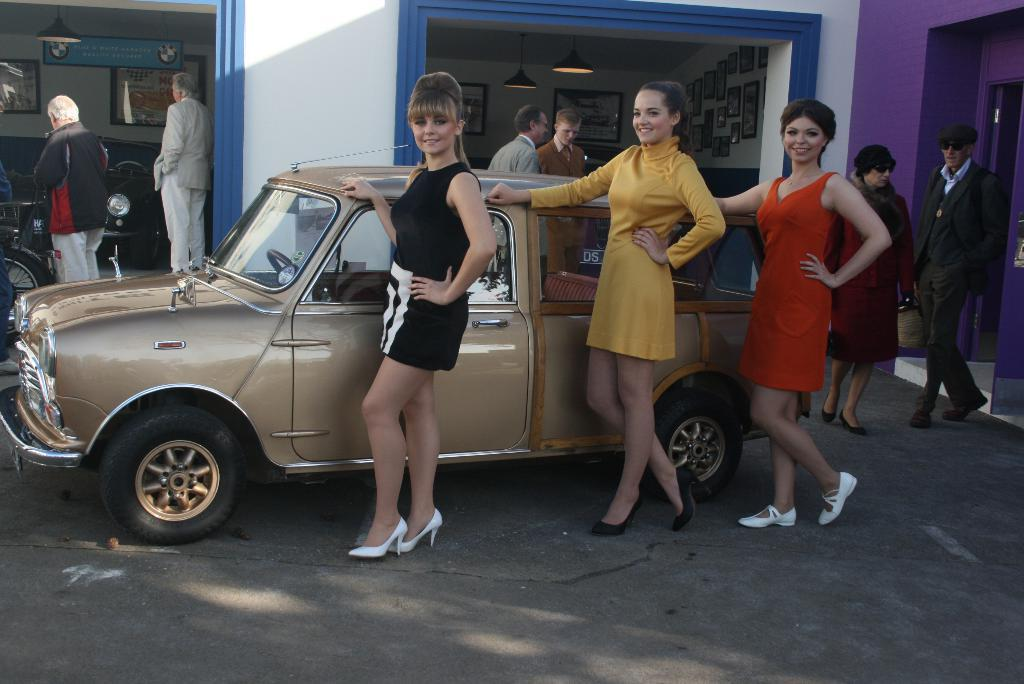How many women are present in the image? There are three women standing in the image. What is the facial expression of the women? The women are smiling. What else can be seen in the image besides the women? There are vehicles, a group of people, frames attached to the wall, and lights in the image. What type of appliance is being used by the company in the image? There is no appliance or company mentioned in the image; it features three women, vehicles, a group of people, frames attached to the wall, and lights. 